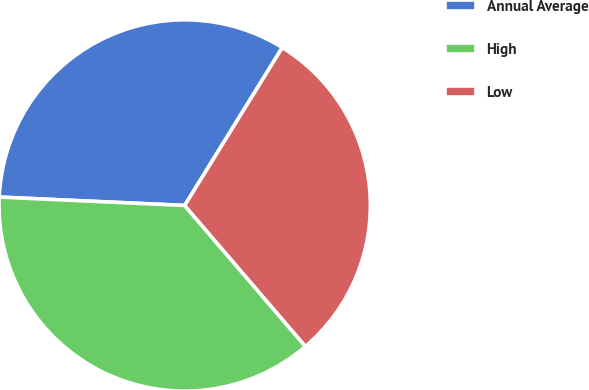Convert chart. <chart><loc_0><loc_0><loc_500><loc_500><pie_chart><fcel>Annual Average<fcel>High<fcel>Low<nl><fcel>33.09%<fcel>36.99%<fcel>29.91%<nl></chart> 